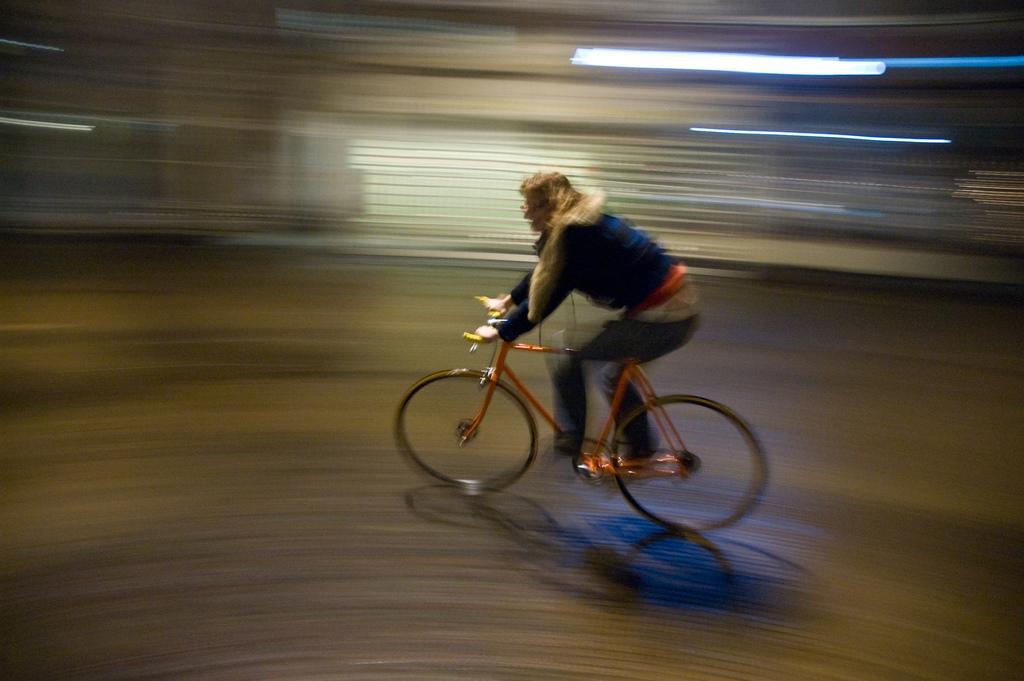How would you summarize this image in a sentence or two? In the middle of the image a person is riding a bicycle. 